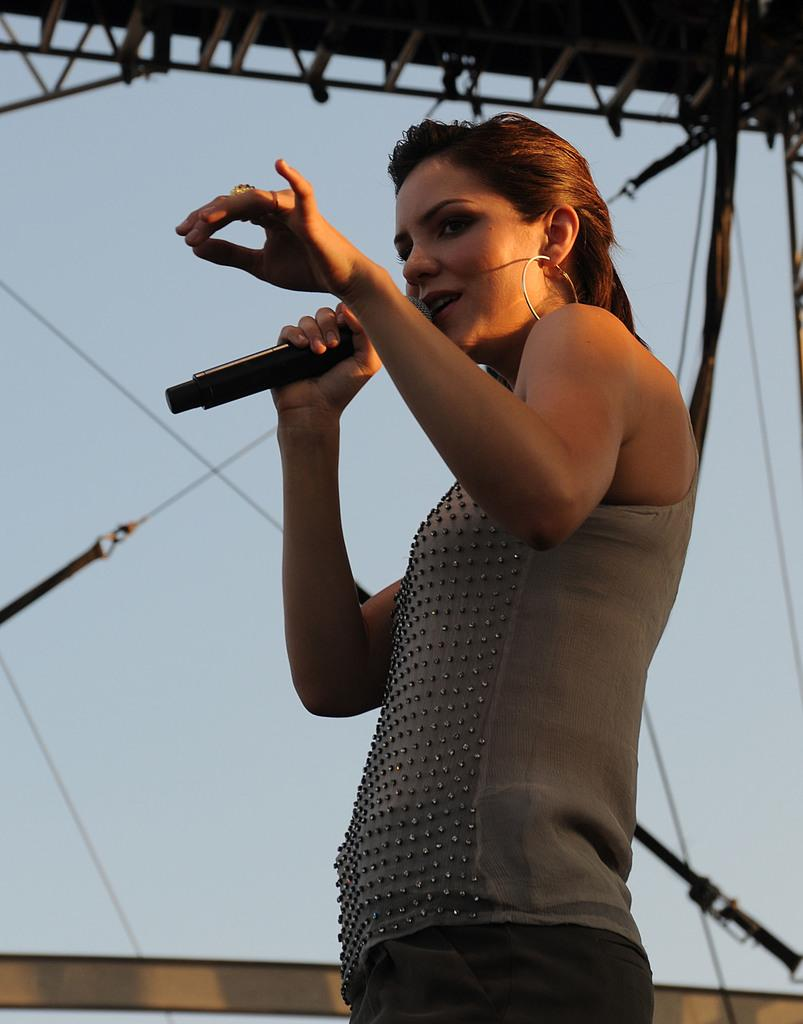What is the main subject of the image? The main subject of the image is a woman. What is the woman doing in the image? The woman is performing in the image. What tool is the woman using during her performance? The woman is using a microphone in the image. What type of paste is being used by the woman in the image? There is no paste visible or mentioned in the image; the woman is using a microphone during her performance. 